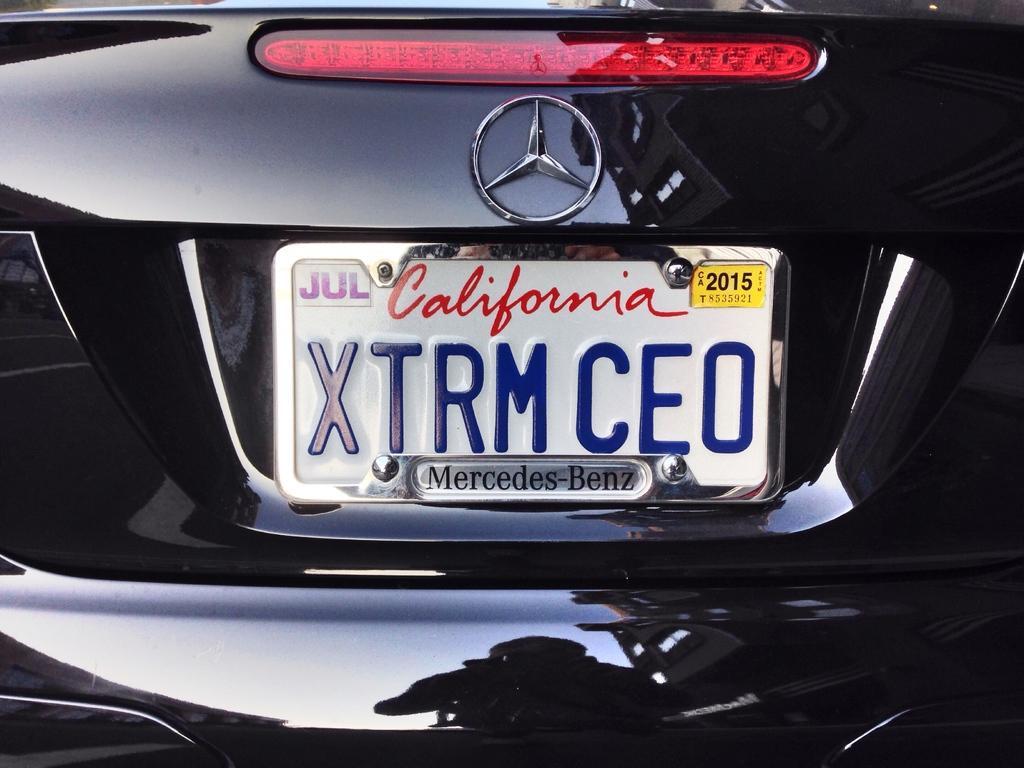Could you give a brief overview of what you see in this image? In this image, we can see a logo, number plate with some text and sticker. It is the backside of the car. On the car, we can see some reflections. Here we can see a person, building and sky. 